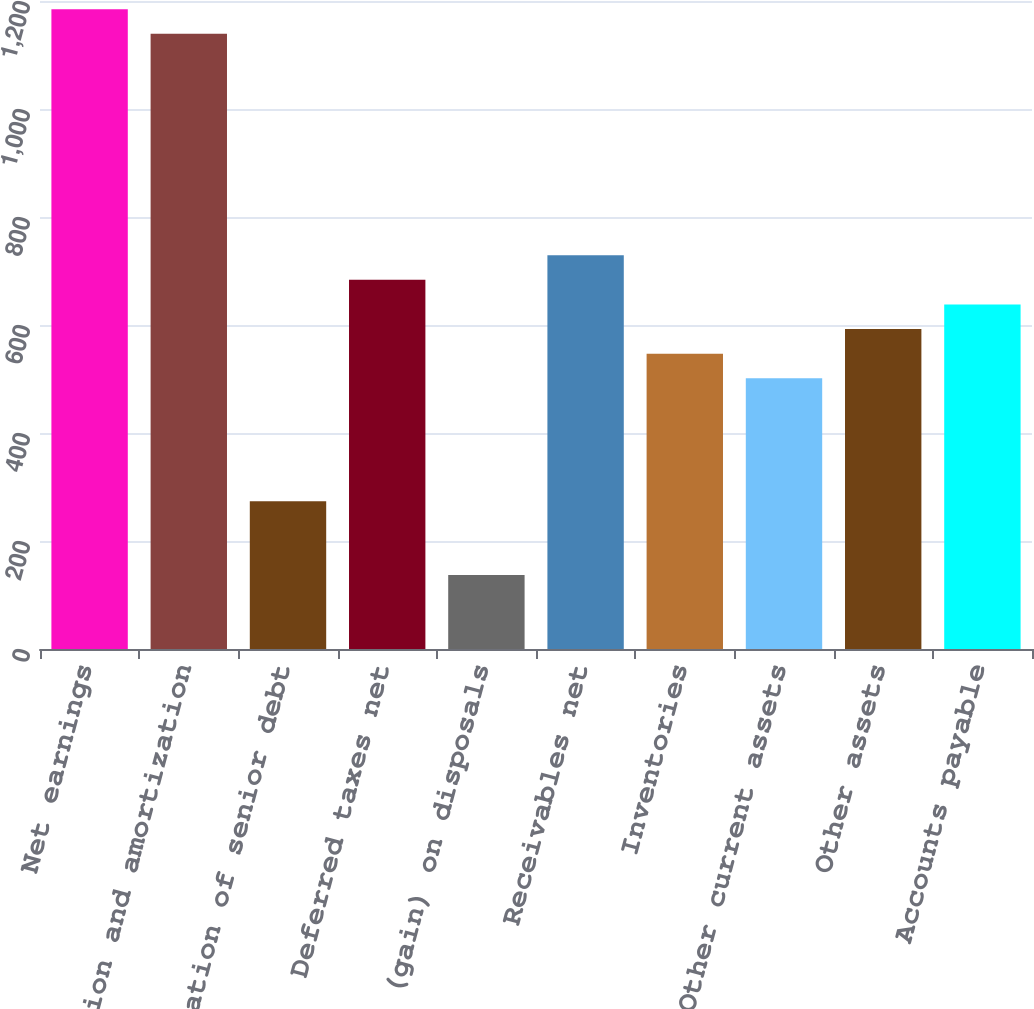<chart> <loc_0><loc_0><loc_500><loc_500><bar_chart><fcel>Net earnings<fcel>Depreciation and amortization<fcel>Amortization of senior debt<fcel>Deferred taxes net<fcel>Net loss (gain) on disposals<fcel>Receivables net<fcel>Inventories<fcel>Other current assets<fcel>Other assets<fcel>Accounts payable<nl><fcel>1184.92<fcel>1139.35<fcel>273.52<fcel>683.65<fcel>136.81<fcel>729.22<fcel>546.94<fcel>501.37<fcel>592.51<fcel>638.08<nl></chart> 